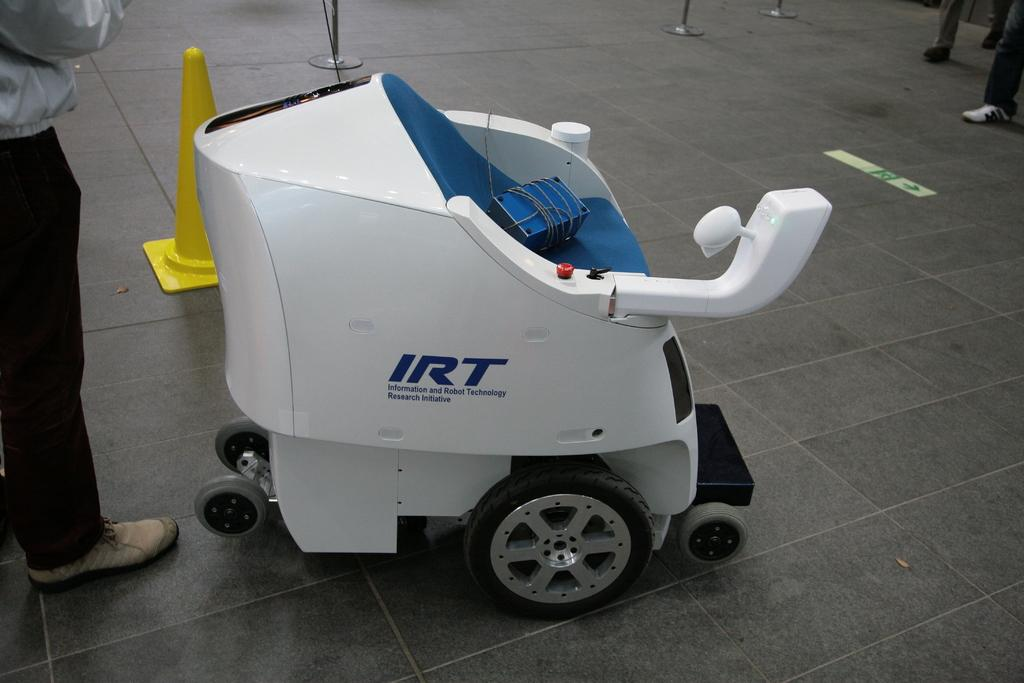<image>
Offer a succinct explanation of the picture presented. A person stands behind an electric mobility device made by a company called IRT. 